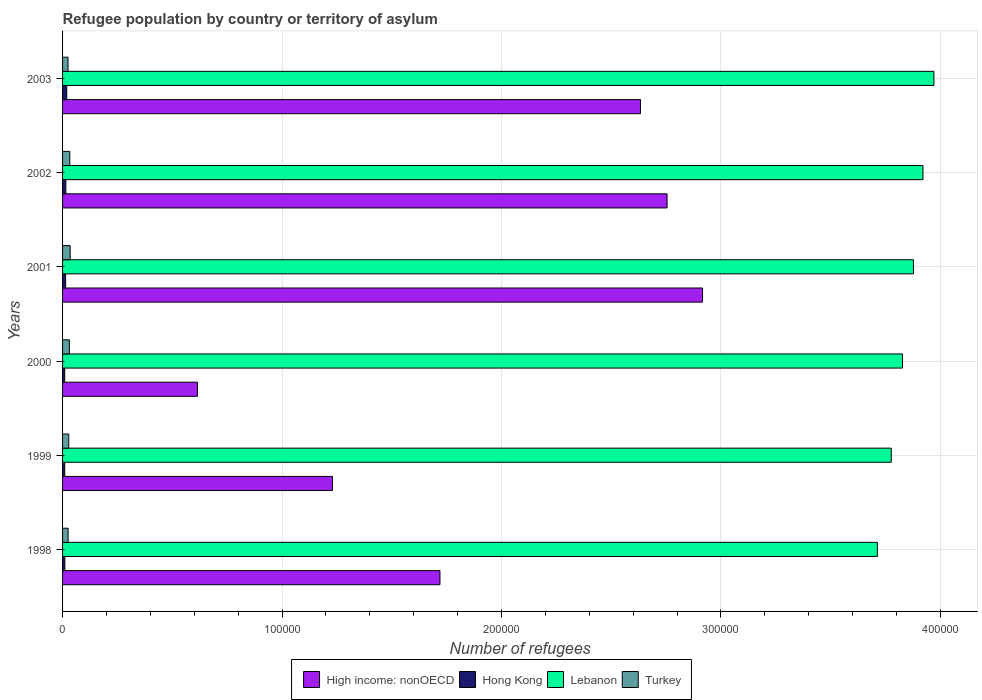How many different coloured bars are there?
Give a very brief answer. 4. How many groups of bars are there?
Ensure brevity in your answer.  6. Are the number of bars per tick equal to the number of legend labels?
Your answer should be very brief. Yes. How many bars are there on the 3rd tick from the top?
Make the answer very short. 4. How many bars are there on the 4th tick from the bottom?
Make the answer very short. 4. In how many cases, is the number of bars for a given year not equal to the number of legend labels?
Provide a succinct answer. 0. What is the number of refugees in High income: nonOECD in 2000?
Provide a short and direct response. 6.15e+04. Across all years, what is the maximum number of refugees in Lebanon?
Make the answer very short. 3.97e+05. Across all years, what is the minimum number of refugees in Hong Kong?
Your answer should be compact. 974. In which year was the number of refugees in High income: nonOECD maximum?
Your answer should be very brief. 2001. What is the total number of refugees in High income: nonOECD in the graph?
Provide a succinct answer. 1.19e+06. What is the difference between the number of refugees in Hong Kong in 2000 and that in 2001?
Your answer should be compact. -407. What is the difference between the number of refugees in Lebanon in 1998 and the number of refugees in Hong Kong in 2003?
Offer a very short reply. 3.69e+05. What is the average number of refugees in High income: nonOECD per year?
Provide a short and direct response. 1.98e+05. In the year 1999, what is the difference between the number of refugees in High income: nonOECD and number of refugees in Hong Kong?
Provide a succinct answer. 1.22e+05. What is the ratio of the number of refugees in Hong Kong in 2000 to that in 2001?
Ensure brevity in your answer.  0.71. Is the number of refugees in Hong Kong in 1998 less than that in 2003?
Keep it short and to the point. Yes. Is the difference between the number of refugees in High income: nonOECD in 2001 and 2003 greater than the difference between the number of refugees in Hong Kong in 2001 and 2003?
Your response must be concise. Yes. What is the difference between the highest and the second highest number of refugees in Turkey?
Make the answer very short. 171. What is the difference between the highest and the lowest number of refugees in Hong Kong?
Ensure brevity in your answer.  928. In how many years, is the number of refugees in Turkey greater than the average number of refugees in Turkey taken over all years?
Keep it short and to the point. 3. Is it the case that in every year, the sum of the number of refugees in High income: nonOECD and number of refugees in Lebanon is greater than the sum of number of refugees in Hong Kong and number of refugees in Turkey?
Keep it short and to the point. Yes. What does the 4th bar from the top in 2000 represents?
Your answer should be compact. High income: nonOECD. What does the 3rd bar from the bottom in 2003 represents?
Make the answer very short. Lebanon. Is it the case that in every year, the sum of the number of refugees in Hong Kong and number of refugees in High income: nonOECD is greater than the number of refugees in Turkey?
Provide a succinct answer. Yes. Are all the bars in the graph horizontal?
Your response must be concise. Yes. How many years are there in the graph?
Keep it short and to the point. 6. What is the difference between two consecutive major ticks on the X-axis?
Offer a terse response. 1.00e+05. Are the values on the major ticks of X-axis written in scientific E-notation?
Your answer should be compact. No. Does the graph contain any zero values?
Your answer should be compact. No. Does the graph contain grids?
Give a very brief answer. Yes. Where does the legend appear in the graph?
Offer a terse response. Bottom center. How many legend labels are there?
Your answer should be very brief. 4. What is the title of the graph?
Your answer should be very brief. Refugee population by country or territory of asylum. What is the label or title of the X-axis?
Your answer should be compact. Number of refugees. What is the label or title of the Y-axis?
Provide a short and direct response. Years. What is the Number of refugees in High income: nonOECD in 1998?
Offer a terse response. 1.72e+05. What is the Number of refugees in Hong Kong in 1998?
Your response must be concise. 1039. What is the Number of refugees of Lebanon in 1998?
Give a very brief answer. 3.71e+05. What is the Number of refugees in Turkey in 1998?
Offer a terse response. 2528. What is the Number of refugees in High income: nonOECD in 1999?
Offer a very short reply. 1.23e+05. What is the Number of refugees in Hong Kong in 1999?
Offer a very short reply. 974. What is the Number of refugees in Lebanon in 1999?
Keep it short and to the point. 3.78e+05. What is the Number of refugees in Turkey in 1999?
Give a very brief answer. 2815. What is the Number of refugees in High income: nonOECD in 2000?
Offer a very short reply. 6.15e+04. What is the Number of refugees in Hong Kong in 2000?
Offer a terse response. 983. What is the Number of refugees in Lebanon in 2000?
Your answer should be compact. 3.83e+05. What is the Number of refugees in Turkey in 2000?
Give a very brief answer. 3103. What is the Number of refugees in High income: nonOECD in 2001?
Provide a succinct answer. 2.92e+05. What is the Number of refugees of Hong Kong in 2001?
Offer a terse response. 1390. What is the Number of refugees of Lebanon in 2001?
Your answer should be very brief. 3.88e+05. What is the Number of refugees in Turkey in 2001?
Keep it short and to the point. 3472. What is the Number of refugees in High income: nonOECD in 2002?
Offer a very short reply. 2.75e+05. What is the Number of refugees in Hong Kong in 2002?
Your response must be concise. 1496. What is the Number of refugees of Lebanon in 2002?
Make the answer very short. 3.92e+05. What is the Number of refugees in Turkey in 2002?
Offer a terse response. 3301. What is the Number of refugees of High income: nonOECD in 2003?
Provide a short and direct response. 2.63e+05. What is the Number of refugees in Hong Kong in 2003?
Make the answer very short. 1902. What is the Number of refugees of Lebanon in 2003?
Provide a short and direct response. 3.97e+05. What is the Number of refugees in Turkey in 2003?
Keep it short and to the point. 2490. Across all years, what is the maximum Number of refugees of High income: nonOECD?
Your answer should be very brief. 2.92e+05. Across all years, what is the maximum Number of refugees in Hong Kong?
Offer a terse response. 1902. Across all years, what is the maximum Number of refugees of Lebanon?
Provide a succinct answer. 3.97e+05. Across all years, what is the maximum Number of refugees of Turkey?
Offer a terse response. 3472. Across all years, what is the minimum Number of refugees in High income: nonOECD?
Keep it short and to the point. 6.15e+04. Across all years, what is the minimum Number of refugees in Hong Kong?
Give a very brief answer. 974. Across all years, what is the minimum Number of refugees in Lebanon?
Keep it short and to the point. 3.71e+05. Across all years, what is the minimum Number of refugees in Turkey?
Your answer should be compact. 2490. What is the total Number of refugees in High income: nonOECD in the graph?
Provide a short and direct response. 1.19e+06. What is the total Number of refugees in Hong Kong in the graph?
Offer a very short reply. 7784. What is the total Number of refugees in Lebanon in the graph?
Provide a short and direct response. 2.31e+06. What is the total Number of refugees of Turkey in the graph?
Provide a succinct answer. 1.77e+04. What is the difference between the Number of refugees in High income: nonOECD in 1998 and that in 1999?
Ensure brevity in your answer.  4.90e+04. What is the difference between the Number of refugees of Hong Kong in 1998 and that in 1999?
Provide a short and direct response. 65. What is the difference between the Number of refugees in Lebanon in 1998 and that in 1999?
Your answer should be very brief. -6318. What is the difference between the Number of refugees in Turkey in 1998 and that in 1999?
Offer a very short reply. -287. What is the difference between the Number of refugees of High income: nonOECD in 1998 and that in 2000?
Your answer should be very brief. 1.11e+05. What is the difference between the Number of refugees of Hong Kong in 1998 and that in 2000?
Provide a succinct answer. 56. What is the difference between the Number of refugees in Lebanon in 1998 and that in 2000?
Provide a short and direct response. -1.14e+04. What is the difference between the Number of refugees in Turkey in 1998 and that in 2000?
Your response must be concise. -575. What is the difference between the Number of refugees of High income: nonOECD in 1998 and that in 2001?
Provide a short and direct response. -1.20e+05. What is the difference between the Number of refugees in Hong Kong in 1998 and that in 2001?
Make the answer very short. -351. What is the difference between the Number of refugees of Lebanon in 1998 and that in 2001?
Offer a very short reply. -1.64e+04. What is the difference between the Number of refugees in Turkey in 1998 and that in 2001?
Provide a succinct answer. -944. What is the difference between the Number of refugees in High income: nonOECD in 1998 and that in 2002?
Make the answer very short. -1.03e+05. What is the difference between the Number of refugees in Hong Kong in 1998 and that in 2002?
Offer a very short reply. -457. What is the difference between the Number of refugees in Lebanon in 1998 and that in 2002?
Ensure brevity in your answer.  -2.08e+04. What is the difference between the Number of refugees in Turkey in 1998 and that in 2002?
Give a very brief answer. -773. What is the difference between the Number of refugees in High income: nonOECD in 1998 and that in 2003?
Offer a very short reply. -9.14e+04. What is the difference between the Number of refugees in Hong Kong in 1998 and that in 2003?
Provide a succinct answer. -863. What is the difference between the Number of refugees in Lebanon in 1998 and that in 2003?
Make the answer very short. -2.58e+04. What is the difference between the Number of refugees of High income: nonOECD in 1999 and that in 2000?
Your answer should be very brief. 6.15e+04. What is the difference between the Number of refugees of Hong Kong in 1999 and that in 2000?
Give a very brief answer. -9. What is the difference between the Number of refugees in Lebanon in 1999 and that in 2000?
Make the answer very short. -5132. What is the difference between the Number of refugees of Turkey in 1999 and that in 2000?
Ensure brevity in your answer.  -288. What is the difference between the Number of refugees in High income: nonOECD in 1999 and that in 2001?
Give a very brief answer. -1.69e+05. What is the difference between the Number of refugees in Hong Kong in 1999 and that in 2001?
Your answer should be compact. -416. What is the difference between the Number of refugees of Lebanon in 1999 and that in 2001?
Provide a succinct answer. -1.01e+04. What is the difference between the Number of refugees in Turkey in 1999 and that in 2001?
Keep it short and to the point. -657. What is the difference between the Number of refugees of High income: nonOECD in 1999 and that in 2002?
Give a very brief answer. -1.52e+05. What is the difference between the Number of refugees in Hong Kong in 1999 and that in 2002?
Make the answer very short. -522. What is the difference between the Number of refugees in Lebanon in 1999 and that in 2002?
Offer a terse response. -1.44e+04. What is the difference between the Number of refugees in Turkey in 1999 and that in 2002?
Ensure brevity in your answer.  -486. What is the difference between the Number of refugees in High income: nonOECD in 1999 and that in 2003?
Give a very brief answer. -1.40e+05. What is the difference between the Number of refugees in Hong Kong in 1999 and that in 2003?
Provide a succinct answer. -928. What is the difference between the Number of refugees of Lebanon in 1999 and that in 2003?
Offer a very short reply. -1.94e+04. What is the difference between the Number of refugees in Turkey in 1999 and that in 2003?
Make the answer very short. 325. What is the difference between the Number of refugees in High income: nonOECD in 2000 and that in 2001?
Your answer should be compact. -2.30e+05. What is the difference between the Number of refugees of Hong Kong in 2000 and that in 2001?
Ensure brevity in your answer.  -407. What is the difference between the Number of refugees in Lebanon in 2000 and that in 2001?
Your response must be concise. -4989. What is the difference between the Number of refugees of Turkey in 2000 and that in 2001?
Your response must be concise. -369. What is the difference between the Number of refugees in High income: nonOECD in 2000 and that in 2002?
Keep it short and to the point. -2.14e+05. What is the difference between the Number of refugees in Hong Kong in 2000 and that in 2002?
Provide a succinct answer. -513. What is the difference between the Number of refugees in Lebanon in 2000 and that in 2002?
Ensure brevity in your answer.  -9309. What is the difference between the Number of refugees of Turkey in 2000 and that in 2002?
Provide a succinct answer. -198. What is the difference between the Number of refugees of High income: nonOECD in 2000 and that in 2003?
Provide a short and direct response. -2.02e+05. What is the difference between the Number of refugees of Hong Kong in 2000 and that in 2003?
Your response must be concise. -919. What is the difference between the Number of refugees of Lebanon in 2000 and that in 2003?
Keep it short and to the point. -1.43e+04. What is the difference between the Number of refugees in Turkey in 2000 and that in 2003?
Your answer should be very brief. 613. What is the difference between the Number of refugees in High income: nonOECD in 2001 and that in 2002?
Offer a terse response. 1.62e+04. What is the difference between the Number of refugees of Hong Kong in 2001 and that in 2002?
Provide a succinct answer. -106. What is the difference between the Number of refugees of Lebanon in 2001 and that in 2002?
Offer a very short reply. -4320. What is the difference between the Number of refugees of Turkey in 2001 and that in 2002?
Your answer should be very brief. 171. What is the difference between the Number of refugees in High income: nonOECD in 2001 and that in 2003?
Offer a terse response. 2.83e+04. What is the difference between the Number of refugees in Hong Kong in 2001 and that in 2003?
Provide a short and direct response. -512. What is the difference between the Number of refugees in Lebanon in 2001 and that in 2003?
Provide a short and direct response. -9321. What is the difference between the Number of refugees of Turkey in 2001 and that in 2003?
Your answer should be compact. 982. What is the difference between the Number of refugees of High income: nonOECD in 2002 and that in 2003?
Offer a very short reply. 1.21e+04. What is the difference between the Number of refugees in Hong Kong in 2002 and that in 2003?
Give a very brief answer. -406. What is the difference between the Number of refugees in Lebanon in 2002 and that in 2003?
Your response must be concise. -5001. What is the difference between the Number of refugees in Turkey in 2002 and that in 2003?
Your response must be concise. 811. What is the difference between the Number of refugees of High income: nonOECD in 1998 and the Number of refugees of Hong Kong in 1999?
Provide a short and direct response. 1.71e+05. What is the difference between the Number of refugees in High income: nonOECD in 1998 and the Number of refugees in Lebanon in 1999?
Make the answer very short. -2.06e+05. What is the difference between the Number of refugees of High income: nonOECD in 1998 and the Number of refugees of Turkey in 1999?
Your answer should be very brief. 1.69e+05. What is the difference between the Number of refugees in Hong Kong in 1998 and the Number of refugees in Lebanon in 1999?
Keep it short and to the point. -3.77e+05. What is the difference between the Number of refugees in Hong Kong in 1998 and the Number of refugees in Turkey in 1999?
Provide a short and direct response. -1776. What is the difference between the Number of refugees of Lebanon in 1998 and the Number of refugees of Turkey in 1999?
Your answer should be compact. 3.68e+05. What is the difference between the Number of refugees of High income: nonOECD in 1998 and the Number of refugees of Hong Kong in 2000?
Offer a terse response. 1.71e+05. What is the difference between the Number of refugees in High income: nonOECD in 1998 and the Number of refugees in Lebanon in 2000?
Make the answer very short. -2.11e+05. What is the difference between the Number of refugees in High income: nonOECD in 1998 and the Number of refugees in Turkey in 2000?
Your answer should be compact. 1.69e+05. What is the difference between the Number of refugees of Hong Kong in 1998 and the Number of refugees of Lebanon in 2000?
Your response must be concise. -3.82e+05. What is the difference between the Number of refugees of Hong Kong in 1998 and the Number of refugees of Turkey in 2000?
Offer a terse response. -2064. What is the difference between the Number of refugees in Lebanon in 1998 and the Number of refugees in Turkey in 2000?
Offer a terse response. 3.68e+05. What is the difference between the Number of refugees in High income: nonOECD in 1998 and the Number of refugees in Hong Kong in 2001?
Your response must be concise. 1.71e+05. What is the difference between the Number of refugees of High income: nonOECD in 1998 and the Number of refugees of Lebanon in 2001?
Your answer should be very brief. -2.16e+05. What is the difference between the Number of refugees in High income: nonOECD in 1998 and the Number of refugees in Turkey in 2001?
Keep it short and to the point. 1.69e+05. What is the difference between the Number of refugees in Hong Kong in 1998 and the Number of refugees in Lebanon in 2001?
Ensure brevity in your answer.  -3.87e+05. What is the difference between the Number of refugees in Hong Kong in 1998 and the Number of refugees in Turkey in 2001?
Your answer should be compact. -2433. What is the difference between the Number of refugees in Lebanon in 1998 and the Number of refugees in Turkey in 2001?
Ensure brevity in your answer.  3.68e+05. What is the difference between the Number of refugees in High income: nonOECD in 1998 and the Number of refugees in Hong Kong in 2002?
Offer a very short reply. 1.70e+05. What is the difference between the Number of refugees in High income: nonOECD in 1998 and the Number of refugees in Lebanon in 2002?
Your response must be concise. -2.20e+05. What is the difference between the Number of refugees of High income: nonOECD in 1998 and the Number of refugees of Turkey in 2002?
Give a very brief answer. 1.69e+05. What is the difference between the Number of refugees of Hong Kong in 1998 and the Number of refugees of Lebanon in 2002?
Your answer should be very brief. -3.91e+05. What is the difference between the Number of refugees of Hong Kong in 1998 and the Number of refugees of Turkey in 2002?
Offer a terse response. -2262. What is the difference between the Number of refugees in Lebanon in 1998 and the Number of refugees in Turkey in 2002?
Provide a short and direct response. 3.68e+05. What is the difference between the Number of refugees of High income: nonOECD in 1998 and the Number of refugees of Hong Kong in 2003?
Provide a succinct answer. 1.70e+05. What is the difference between the Number of refugees in High income: nonOECD in 1998 and the Number of refugees in Lebanon in 2003?
Ensure brevity in your answer.  -2.25e+05. What is the difference between the Number of refugees of High income: nonOECD in 1998 and the Number of refugees of Turkey in 2003?
Make the answer very short. 1.69e+05. What is the difference between the Number of refugees in Hong Kong in 1998 and the Number of refugees in Lebanon in 2003?
Your response must be concise. -3.96e+05. What is the difference between the Number of refugees of Hong Kong in 1998 and the Number of refugees of Turkey in 2003?
Provide a succinct answer. -1451. What is the difference between the Number of refugees of Lebanon in 1998 and the Number of refugees of Turkey in 2003?
Make the answer very short. 3.69e+05. What is the difference between the Number of refugees of High income: nonOECD in 1999 and the Number of refugees of Hong Kong in 2000?
Keep it short and to the point. 1.22e+05. What is the difference between the Number of refugees in High income: nonOECD in 1999 and the Number of refugees in Lebanon in 2000?
Offer a terse response. -2.60e+05. What is the difference between the Number of refugees of High income: nonOECD in 1999 and the Number of refugees of Turkey in 2000?
Keep it short and to the point. 1.20e+05. What is the difference between the Number of refugees of Hong Kong in 1999 and the Number of refugees of Lebanon in 2000?
Your answer should be very brief. -3.82e+05. What is the difference between the Number of refugees in Hong Kong in 1999 and the Number of refugees in Turkey in 2000?
Your answer should be very brief. -2129. What is the difference between the Number of refugees of Lebanon in 1999 and the Number of refugees of Turkey in 2000?
Keep it short and to the point. 3.75e+05. What is the difference between the Number of refugees in High income: nonOECD in 1999 and the Number of refugees in Hong Kong in 2001?
Your answer should be compact. 1.22e+05. What is the difference between the Number of refugees in High income: nonOECD in 1999 and the Number of refugees in Lebanon in 2001?
Your response must be concise. -2.65e+05. What is the difference between the Number of refugees of High income: nonOECD in 1999 and the Number of refugees of Turkey in 2001?
Your response must be concise. 1.19e+05. What is the difference between the Number of refugees of Hong Kong in 1999 and the Number of refugees of Lebanon in 2001?
Your answer should be very brief. -3.87e+05. What is the difference between the Number of refugees of Hong Kong in 1999 and the Number of refugees of Turkey in 2001?
Offer a very short reply. -2498. What is the difference between the Number of refugees in Lebanon in 1999 and the Number of refugees in Turkey in 2001?
Ensure brevity in your answer.  3.74e+05. What is the difference between the Number of refugees in High income: nonOECD in 1999 and the Number of refugees in Hong Kong in 2002?
Keep it short and to the point. 1.21e+05. What is the difference between the Number of refugees of High income: nonOECD in 1999 and the Number of refugees of Lebanon in 2002?
Make the answer very short. -2.69e+05. What is the difference between the Number of refugees in High income: nonOECD in 1999 and the Number of refugees in Turkey in 2002?
Provide a short and direct response. 1.20e+05. What is the difference between the Number of refugees in Hong Kong in 1999 and the Number of refugees in Lebanon in 2002?
Make the answer very short. -3.91e+05. What is the difference between the Number of refugees in Hong Kong in 1999 and the Number of refugees in Turkey in 2002?
Provide a succinct answer. -2327. What is the difference between the Number of refugees of Lebanon in 1999 and the Number of refugees of Turkey in 2002?
Your response must be concise. 3.74e+05. What is the difference between the Number of refugees in High income: nonOECD in 1999 and the Number of refugees in Hong Kong in 2003?
Give a very brief answer. 1.21e+05. What is the difference between the Number of refugees in High income: nonOECD in 1999 and the Number of refugees in Lebanon in 2003?
Your answer should be compact. -2.74e+05. What is the difference between the Number of refugees in High income: nonOECD in 1999 and the Number of refugees in Turkey in 2003?
Offer a very short reply. 1.20e+05. What is the difference between the Number of refugees in Hong Kong in 1999 and the Number of refugees in Lebanon in 2003?
Your response must be concise. -3.96e+05. What is the difference between the Number of refugees in Hong Kong in 1999 and the Number of refugees in Turkey in 2003?
Your answer should be very brief. -1516. What is the difference between the Number of refugees in Lebanon in 1999 and the Number of refugees in Turkey in 2003?
Your response must be concise. 3.75e+05. What is the difference between the Number of refugees of High income: nonOECD in 2000 and the Number of refugees of Hong Kong in 2001?
Your answer should be compact. 6.01e+04. What is the difference between the Number of refugees of High income: nonOECD in 2000 and the Number of refugees of Lebanon in 2001?
Provide a short and direct response. -3.26e+05. What is the difference between the Number of refugees in High income: nonOECD in 2000 and the Number of refugees in Turkey in 2001?
Your response must be concise. 5.80e+04. What is the difference between the Number of refugees in Hong Kong in 2000 and the Number of refugees in Lebanon in 2001?
Keep it short and to the point. -3.87e+05. What is the difference between the Number of refugees of Hong Kong in 2000 and the Number of refugees of Turkey in 2001?
Offer a very short reply. -2489. What is the difference between the Number of refugees in Lebanon in 2000 and the Number of refugees in Turkey in 2001?
Your response must be concise. 3.79e+05. What is the difference between the Number of refugees in High income: nonOECD in 2000 and the Number of refugees in Hong Kong in 2002?
Keep it short and to the point. 6.00e+04. What is the difference between the Number of refugees in High income: nonOECD in 2000 and the Number of refugees in Lebanon in 2002?
Your answer should be very brief. -3.31e+05. What is the difference between the Number of refugees in High income: nonOECD in 2000 and the Number of refugees in Turkey in 2002?
Offer a very short reply. 5.82e+04. What is the difference between the Number of refugees of Hong Kong in 2000 and the Number of refugees of Lebanon in 2002?
Your answer should be compact. -3.91e+05. What is the difference between the Number of refugees of Hong Kong in 2000 and the Number of refugees of Turkey in 2002?
Ensure brevity in your answer.  -2318. What is the difference between the Number of refugees of Lebanon in 2000 and the Number of refugees of Turkey in 2002?
Keep it short and to the point. 3.79e+05. What is the difference between the Number of refugees in High income: nonOECD in 2000 and the Number of refugees in Hong Kong in 2003?
Offer a terse response. 5.96e+04. What is the difference between the Number of refugees in High income: nonOECD in 2000 and the Number of refugees in Lebanon in 2003?
Your answer should be very brief. -3.36e+05. What is the difference between the Number of refugees of High income: nonOECD in 2000 and the Number of refugees of Turkey in 2003?
Your response must be concise. 5.90e+04. What is the difference between the Number of refugees in Hong Kong in 2000 and the Number of refugees in Lebanon in 2003?
Provide a succinct answer. -3.96e+05. What is the difference between the Number of refugees in Hong Kong in 2000 and the Number of refugees in Turkey in 2003?
Ensure brevity in your answer.  -1507. What is the difference between the Number of refugees in Lebanon in 2000 and the Number of refugees in Turkey in 2003?
Your answer should be compact. 3.80e+05. What is the difference between the Number of refugees of High income: nonOECD in 2001 and the Number of refugees of Hong Kong in 2002?
Offer a terse response. 2.90e+05. What is the difference between the Number of refugees of High income: nonOECD in 2001 and the Number of refugees of Lebanon in 2002?
Your response must be concise. -1.00e+05. What is the difference between the Number of refugees of High income: nonOECD in 2001 and the Number of refugees of Turkey in 2002?
Provide a succinct answer. 2.88e+05. What is the difference between the Number of refugees in Hong Kong in 2001 and the Number of refugees in Lebanon in 2002?
Ensure brevity in your answer.  -3.91e+05. What is the difference between the Number of refugees in Hong Kong in 2001 and the Number of refugees in Turkey in 2002?
Provide a short and direct response. -1911. What is the difference between the Number of refugees in Lebanon in 2001 and the Number of refugees in Turkey in 2002?
Your response must be concise. 3.84e+05. What is the difference between the Number of refugees of High income: nonOECD in 2001 and the Number of refugees of Hong Kong in 2003?
Your response must be concise. 2.90e+05. What is the difference between the Number of refugees in High income: nonOECD in 2001 and the Number of refugees in Lebanon in 2003?
Provide a succinct answer. -1.05e+05. What is the difference between the Number of refugees in High income: nonOECD in 2001 and the Number of refugees in Turkey in 2003?
Provide a succinct answer. 2.89e+05. What is the difference between the Number of refugees in Hong Kong in 2001 and the Number of refugees in Lebanon in 2003?
Make the answer very short. -3.96e+05. What is the difference between the Number of refugees of Hong Kong in 2001 and the Number of refugees of Turkey in 2003?
Keep it short and to the point. -1100. What is the difference between the Number of refugees in Lebanon in 2001 and the Number of refugees in Turkey in 2003?
Provide a short and direct response. 3.85e+05. What is the difference between the Number of refugees in High income: nonOECD in 2002 and the Number of refugees in Hong Kong in 2003?
Provide a short and direct response. 2.74e+05. What is the difference between the Number of refugees in High income: nonOECD in 2002 and the Number of refugees in Lebanon in 2003?
Offer a very short reply. -1.22e+05. What is the difference between the Number of refugees of High income: nonOECD in 2002 and the Number of refugees of Turkey in 2003?
Your answer should be compact. 2.73e+05. What is the difference between the Number of refugees in Hong Kong in 2002 and the Number of refugees in Lebanon in 2003?
Ensure brevity in your answer.  -3.96e+05. What is the difference between the Number of refugees of Hong Kong in 2002 and the Number of refugees of Turkey in 2003?
Your answer should be very brief. -994. What is the difference between the Number of refugees of Lebanon in 2002 and the Number of refugees of Turkey in 2003?
Keep it short and to the point. 3.90e+05. What is the average Number of refugees of High income: nonOECD per year?
Your answer should be compact. 1.98e+05. What is the average Number of refugees in Hong Kong per year?
Provide a succinct answer. 1297.33. What is the average Number of refugees in Lebanon per year?
Ensure brevity in your answer.  3.85e+05. What is the average Number of refugees in Turkey per year?
Your answer should be very brief. 2951.5. In the year 1998, what is the difference between the Number of refugees in High income: nonOECD and Number of refugees in Hong Kong?
Provide a succinct answer. 1.71e+05. In the year 1998, what is the difference between the Number of refugees of High income: nonOECD and Number of refugees of Lebanon?
Your answer should be very brief. -1.99e+05. In the year 1998, what is the difference between the Number of refugees in High income: nonOECD and Number of refugees in Turkey?
Your answer should be compact. 1.69e+05. In the year 1998, what is the difference between the Number of refugees in Hong Kong and Number of refugees in Lebanon?
Your response must be concise. -3.70e+05. In the year 1998, what is the difference between the Number of refugees of Hong Kong and Number of refugees of Turkey?
Your answer should be compact. -1489. In the year 1998, what is the difference between the Number of refugees in Lebanon and Number of refugees in Turkey?
Your answer should be compact. 3.69e+05. In the year 1999, what is the difference between the Number of refugees of High income: nonOECD and Number of refugees of Hong Kong?
Give a very brief answer. 1.22e+05. In the year 1999, what is the difference between the Number of refugees in High income: nonOECD and Number of refugees in Lebanon?
Your answer should be very brief. -2.55e+05. In the year 1999, what is the difference between the Number of refugees in High income: nonOECD and Number of refugees in Turkey?
Make the answer very short. 1.20e+05. In the year 1999, what is the difference between the Number of refugees of Hong Kong and Number of refugees of Lebanon?
Offer a terse response. -3.77e+05. In the year 1999, what is the difference between the Number of refugees in Hong Kong and Number of refugees in Turkey?
Your response must be concise. -1841. In the year 1999, what is the difference between the Number of refugees of Lebanon and Number of refugees of Turkey?
Keep it short and to the point. 3.75e+05. In the year 2000, what is the difference between the Number of refugees of High income: nonOECD and Number of refugees of Hong Kong?
Your answer should be very brief. 6.05e+04. In the year 2000, what is the difference between the Number of refugees in High income: nonOECD and Number of refugees in Lebanon?
Offer a very short reply. -3.21e+05. In the year 2000, what is the difference between the Number of refugees of High income: nonOECD and Number of refugees of Turkey?
Provide a succinct answer. 5.84e+04. In the year 2000, what is the difference between the Number of refugees in Hong Kong and Number of refugees in Lebanon?
Give a very brief answer. -3.82e+05. In the year 2000, what is the difference between the Number of refugees of Hong Kong and Number of refugees of Turkey?
Your answer should be very brief. -2120. In the year 2000, what is the difference between the Number of refugees of Lebanon and Number of refugees of Turkey?
Your answer should be very brief. 3.80e+05. In the year 2001, what is the difference between the Number of refugees of High income: nonOECD and Number of refugees of Hong Kong?
Provide a short and direct response. 2.90e+05. In the year 2001, what is the difference between the Number of refugees of High income: nonOECD and Number of refugees of Lebanon?
Make the answer very short. -9.61e+04. In the year 2001, what is the difference between the Number of refugees in High income: nonOECD and Number of refugees in Turkey?
Give a very brief answer. 2.88e+05. In the year 2001, what is the difference between the Number of refugees in Hong Kong and Number of refugees in Lebanon?
Provide a short and direct response. -3.86e+05. In the year 2001, what is the difference between the Number of refugees in Hong Kong and Number of refugees in Turkey?
Offer a terse response. -2082. In the year 2001, what is the difference between the Number of refugees in Lebanon and Number of refugees in Turkey?
Provide a succinct answer. 3.84e+05. In the year 2002, what is the difference between the Number of refugees in High income: nonOECD and Number of refugees in Hong Kong?
Provide a succinct answer. 2.74e+05. In the year 2002, what is the difference between the Number of refugees of High income: nonOECD and Number of refugees of Lebanon?
Your response must be concise. -1.17e+05. In the year 2002, what is the difference between the Number of refugees of High income: nonOECD and Number of refugees of Turkey?
Your response must be concise. 2.72e+05. In the year 2002, what is the difference between the Number of refugees in Hong Kong and Number of refugees in Lebanon?
Your answer should be compact. -3.91e+05. In the year 2002, what is the difference between the Number of refugees of Hong Kong and Number of refugees of Turkey?
Keep it short and to the point. -1805. In the year 2002, what is the difference between the Number of refugees of Lebanon and Number of refugees of Turkey?
Your answer should be very brief. 3.89e+05. In the year 2003, what is the difference between the Number of refugees of High income: nonOECD and Number of refugees of Hong Kong?
Offer a very short reply. 2.61e+05. In the year 2003, what is the difference between the Number of refugees in High income: nonOECD and Number of refugees in Lebanon?
Provide a succinct answer. -1.34e+05. In the year 2003, what is the difference between the Number of refugees of High income: nonOECD and Number of refugees of Turkey?
Offer a very short reply. 2.61e+05. In the year 2003, what is the difference between the Number of refugees of Hong Kong and Number of refugees of Lebanon?
Make the answer very short. -3.95e+05. In the year 2003, what is the difference between the Number of refugees of Hong Kong and Number of refugees of Turkey?
Provide a succinct answer. -588. In the year 2003, what is the difference between the Number of refugees of Lebanon and Number of refugees of Turkey?
Ensure brevity in your answer.  3.95e+05. What is the ratio of the Number of refugees of High income: nonOECD in 1998 to that in 1999?
Your answer should be compact. 1.4. What is the ratio of the Number of refugees in Hong Kong in 1998 to that in 1999?
Offer a very short reply. 1.07. What is the ratio of the Number of refugees in Lebanon in 1998 to that in 1999?
Ensure brevity in your answer.  0.98. What is the ratio of the Number of refugees of Turkey in 1998 to that in 1999?
Your answer should be compact. 0.9. What is the ratio of the Number of refugees of High income: nonOECD in 1998 to that in 2000?
Your answer should be very brief. 2.8. What is the ratio of the Number of refugees in Hong Kong in 1998 to that in 2000?
Your answer should be compact. 1.06. What is the ratio of the Number of refugees in Lebanon in 1998 to that in 2000?
Provide a short and direct response. 0.97. What is the ratio of the Number of refugees of Turkey in 1998 to that in 2000?
Your answer should be compact. 0.81. What is the ratio of the Number of refugees in High income: nonOECD in 1998 to that in 2001?
Offer a terse response. 0.59. What is the ratio of the Number of refugees in Hong Kong in 1998 to that in 2001?
Provide a succinct answer. 0.75. What is the ratio of the Number of refugees in Lebanon in 1998 to that in 2001?
Make the answer very short. 0.96. What is the ratio of the Number of refugees in Turkey in 1998 to that in 2001?
Offer a terse response. 0.73. What is the ratio of the Number of refugees in High income: nonOECD in 1998 to that in 2002?
Your answer should be compact. 0.62. What is the ratio of the Number of refugees in Hong Kong in 1998 to that in 2002?
Offer a terse response. 0.69. What is the ratio of the Number of refugees in Lebanon in 1998 to that in 2002?
Make the answer very short. 0.95. What is the ratio of the Number of refugees in Turkey in 1998 to that in 2002?
Your answer should be compact. 0.77. What is the ratio of the Number of refugees in High income: nonOECD in 1998 to that in 2003?
Provide a short and direct response. 0.65. What is the ratio of the Number of refugees of Hong Kong in 1998 to that in 2003?
Offer a very short reply. 0.55. What is the ratio of the Number of refugees in Lebanon in 1998 to that in 2003?
Provide a succinct answer. 0.94. What is the ratio of the Number of refugees in Turkey in 1998 to that in 2003?
Your answer should be very brief. 1.02. What is the ratio of the Number of refugees in High income: nonOECD in 1999 to that in 2000?
Your response must be concise. 2. What is the ratio of the Number of refugees of Lebanon in 1999 to that in 2000?
Ensure brevity in your answer.  0.99. What is the ratio of the Number of refugees in Turkey in 1999 to that in 2000?
Your response must be concise. 0.91. What is the ratio of the Number of refugees of High income: nonOECD in 1999 to that in 2001?
Offer a very short reply. 0.42. What is the ratio of the Number of refugees of Hong Kong in 1999 to that in 2001?
Provide a short and direct response. 0.7. What is the ratio of the Number of refugees of Lebanon in 1999 to that in 2001?
Provide a succinct answer. 0.97. What is the ratio of the Number of refugees of Turkey in 1999 to that in 2001?
Offer a terse response. 0.81. What is the ratio of the Number of refugees in High income: nonOECD in 1999 to that in 2002?
Your response must be concise. 0.45. What is the ratio of the Number of refugees in Hong Kong in 1999 to that in 2002?
Make the answer very short. 0.65. What is the ratio of the Number of refugees in Lebanon in 1999 to that in 2002?
Keep it short and to the point. 0.96. What is the ratio of the Number of refugees in Turkey in 1999 to that in 2002?
Provide a short and direct response. 0.85. What is the ratio of the Number of refugees in High income: nonOECD in 1999 to that in 2003?
Give a very brief answer. 0.47. What is the ratio of the Number of refugees of Hong Kong in 1999 to that in 2003?
Provide a succinct answer. 0.51. What is the ratio of the Number of refugees in Lebanon in 1999 to that in 2003?
Provide a short and direct response. 0.95. What is the ratio of the Number of refugees of Turkey in 1999 to that in 2003?
Your answer should be very brief. 1.13. What is the ratio of the Number of refugees of High income: nonOECD in 2000 to that in 2001?
Ensure brevity in your answer.  0.21. What is the ratio of the Number of refugees in Hong Kong in 2000 to that in 2001?
Give a very brief answer. 0.71. What is the ratio of the Number of refugees of Lebanon in 2000 to that in 2001?
Your response must be concise. 0.99. What is the ratio of the Number of refugees of Turkey in 2000 to that in 2001?
Provide a succinct answer. 0.89. What is the ratio of the Number of refugees in High income: nonOECD in 2000 to that in 2002?
Offer a terse response. 0.22. What is the ratio of the Number of refugees of Hong Kong in 2000 to that in 2002?
Provide a succinct answer. 0.66. What is the ratio of the Number of refugees of Lebanon in 2000 to that in 2002?
Provide a short and direct response. 0.98. What is the ratio of the Number of refugees in High income: nonOECD in 2000 to that in 2003?
Make the answer very short. 0.23. What is the ratio of the Number of refugees of Hong Kong in 2000 to that in 2003?
Keep it short and to the point. 0.52. What is the ratio of the Number of refugees of Turkey in 2000 to that in 2003?
Offer a terse response. 1.25. What is the ratio of the Number of refugees in High income: nonOECD in 2001 to that in 2002?
Your answer should be compact. 1.06. What is the ratio of the Number of refugees of Hong Kong in 2001 to that in 2002?
Your response must be concise. 0.93. What is the ratio of the Number of refugees of Lebanon in 2001 to that in 2002?
Your answer should be very brief. 0.99. What is the ratio of the Number of refugees in Turkey in 2001 to that in 2002?
Keep it short and to the point. 1.05. What is the ratio of the Number of refugees of High income: nonOECD in 2001 to that in 2003?
Keep it short and to the point. 1.11. What is the ratio of the Number of refugees in Hong Kong in 2001 to that in 2003?
Your response must be concise. 0.73. What is the ratio of the Number of refugees of Lebanon in 2001 to that in 2003?
Your answer should be compact. 0.98. What is the ratio of the Number of refugees of Turkey in 2001 to that in 2003?
Offer a terse response. 1.39. What is the ratio of the Number of refugees of High income: nonOECD in 2002 to that in 2003?
Your answer should be very brief. 1.05. What is the ratio of the Number of refugees in Hong Kong in 2002 to that in 2003?
Ensure brevity in your answer.  0.79. What is the ratio of the Number of refugees of Lebanon in 2002 to that in 2003?
Keep it short and to the point. 0.99. What is the ratio of the Number of refugees of Turkey in 2002 to that in 2003?
Keep it short and to the point. 1.33. What is the difference between the highest and the second highest Number of refugees in High income: nonOECD?
Provide a succinct answer. 1.62e+04. What is the difference between the highest and the second highest Number of refugees in Hong Kong?
Provide a succinct answer. 406. What is the difference between the highest and the second highest Number of refugees in Lebanon?
Ensure brevity in your answer.  5001. What is the difference between the highest and the second highest Number of refugees in Turkey?
Give a very brief answer. 171. What is the difference between the highest and the lowest Number of refugees in High income: nonOECD?
Your answer should be very brief. 2.30e+05. What is the difference between the highest and the lowest Number of refugees of Hong Kong?
Provide a short and direct response. 928. What is the difference between the highest and the lowest Number of refugees in Lebanon?
Provide a succinct answer. 2.58e+04. What is the difference between the highest and the lowest Number of refugees of Turkey?
Provide a short and direct response. 982. 